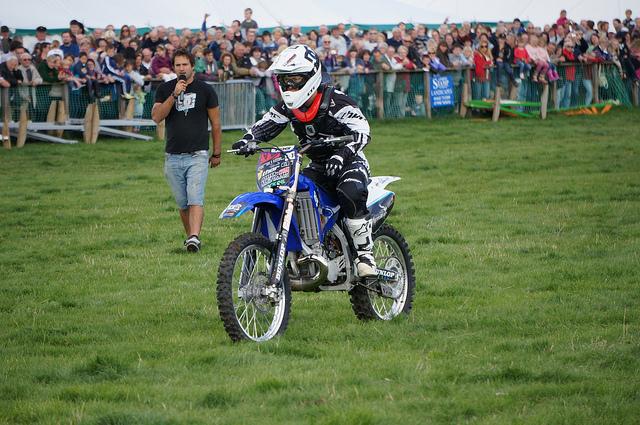Is this a competition?
Answer briefly. Yes. What is he riding?
Keep it brief. Motorbike. What color outfit is the rider wearing?
Short answer required. Black. 